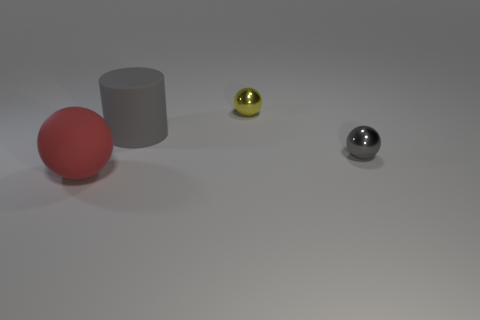Add 4 big gray things. How many objects exist? 8 Subtract all cylinders. How many objects are left? 3 Subtract 0 brown cylinders. How many objects are left? 4 Subtract all tiny matte objects. Subtract all shiny things. How many objects are left? 2 Add 3 gray things. How many gray things are left? 5 Add 2 tiny green things. How many tiny green things exist? 2 